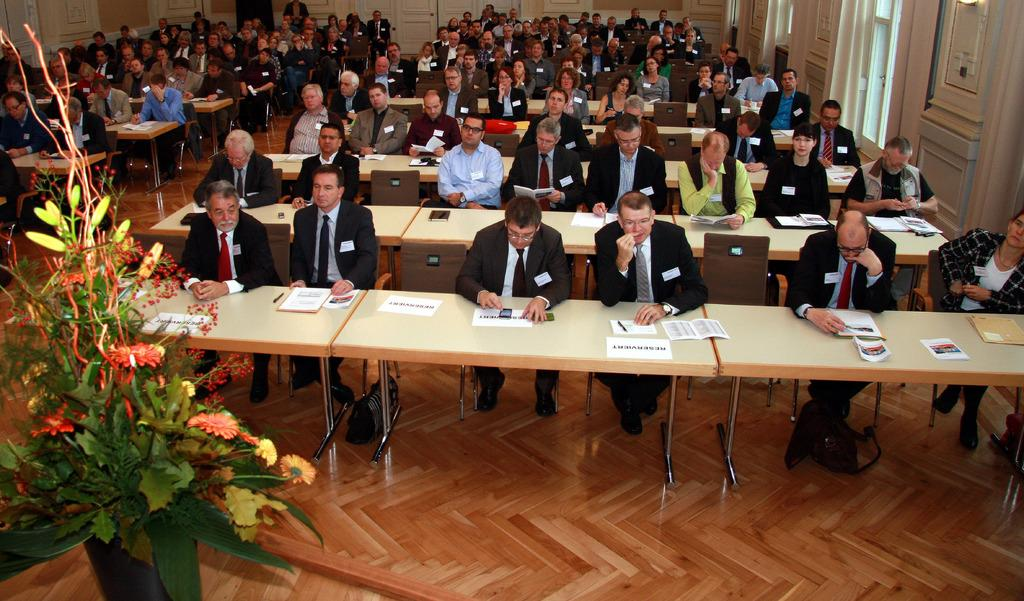What are the people in the image doing? The persons sitting on chairs in the image. What objects are present in the image besides the chairs? There are tables in the image, and papers are present on the tables. What can be seen on the floor in the image? There is a flower vase on the floor. What architectural feature is visible in the image? There is a door in the image. What type of engine can be seen in the image? There is no engine present in the image. What view can be seen through the door in the image? The image does not show a view through the door, as it only depicts the door itself. 